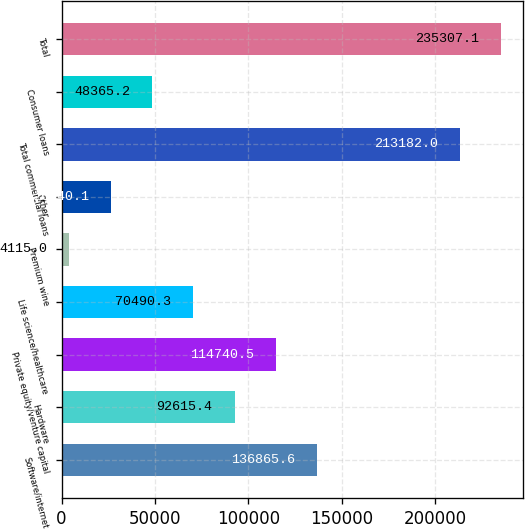Convert chart to OTSL. <chart><loc_0><loc_0><loc_500><loc_500><bar_chart><fcel>Software/internet<fcel>Hardware<fcel>Private equity/venture capital<fcel>Life science/healthcare<fcel>Premium wine<fcel>Other<fcel>Total commercial loans<fcel>Consumer loans<fcel>Total<nl><fcel>136866<fcel>92615.4<fcel>114740<fcel>70490.3<fcel>4115<fcel>26240.1<fcel>213182<fcel>48365.2<fcel>235307<nl></chart> 